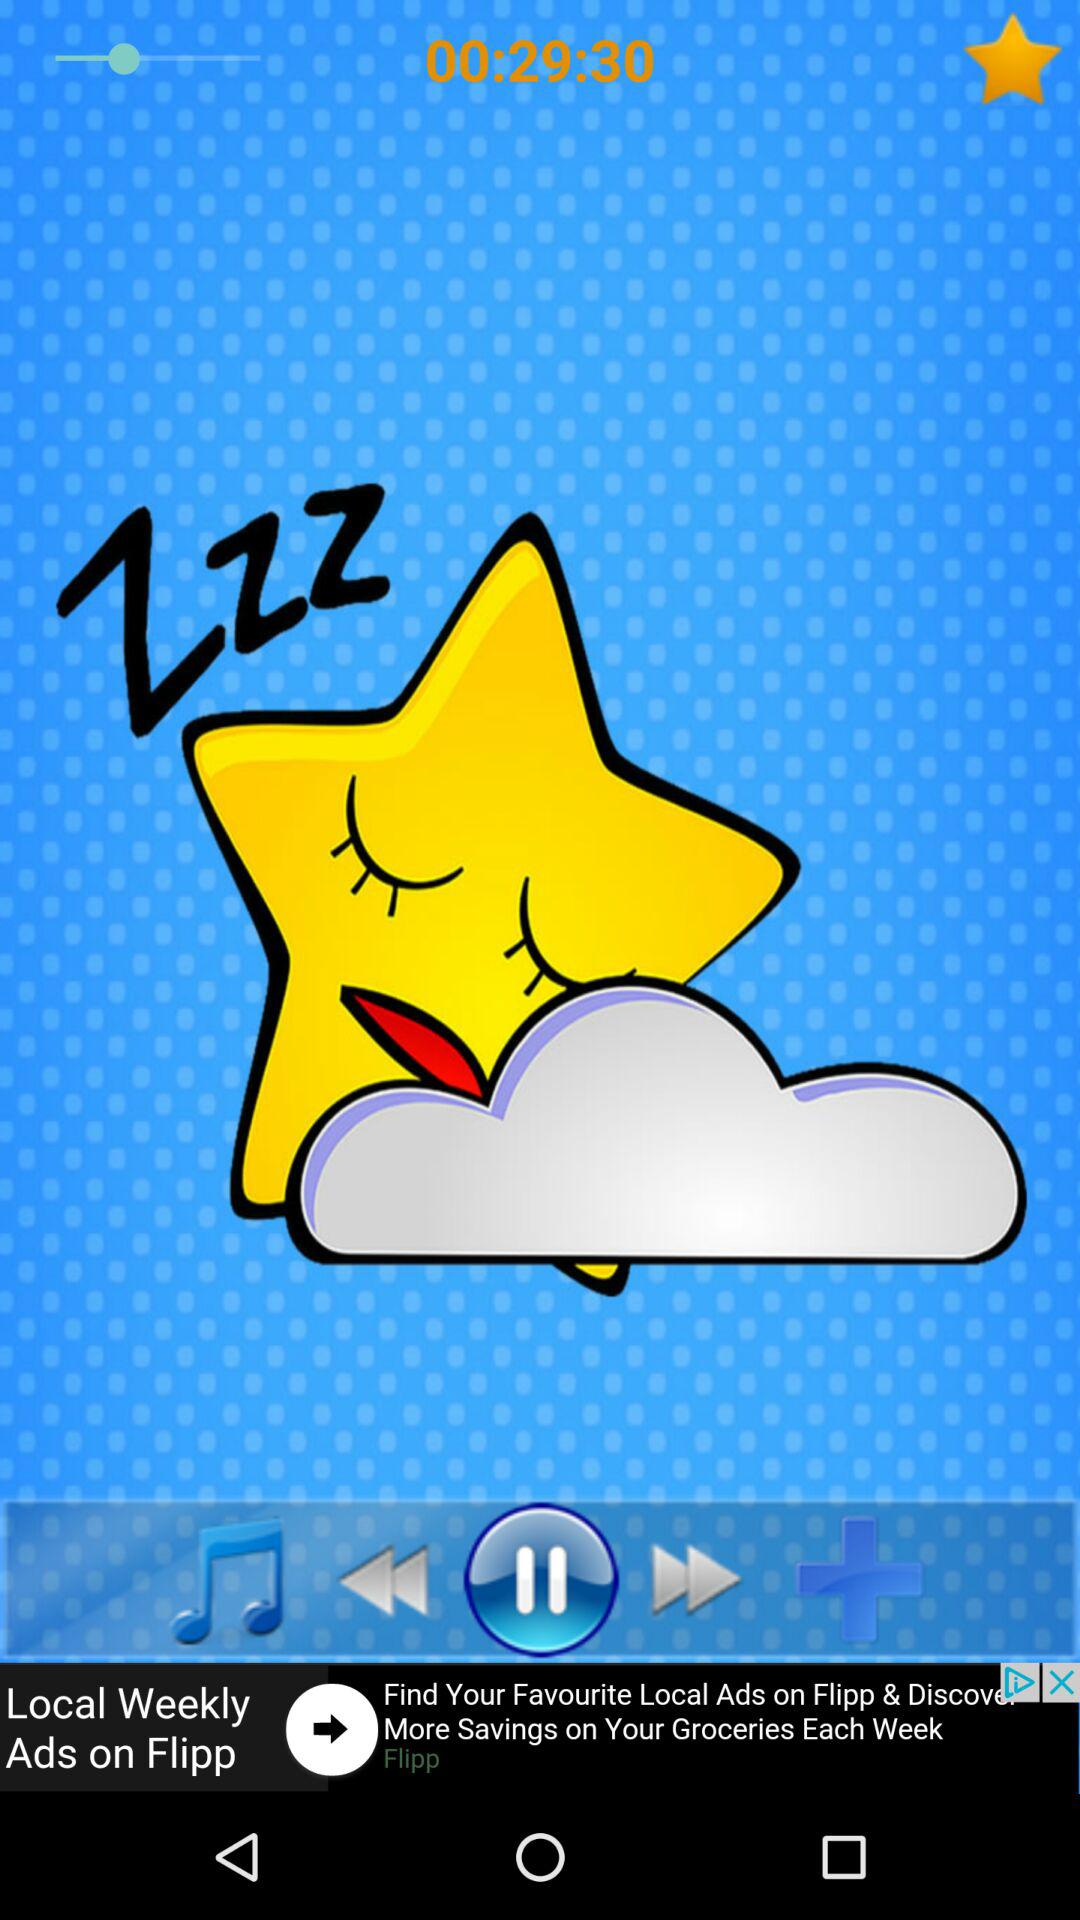What is the time duration? The time duration is 29 minutes 30 seconds. 